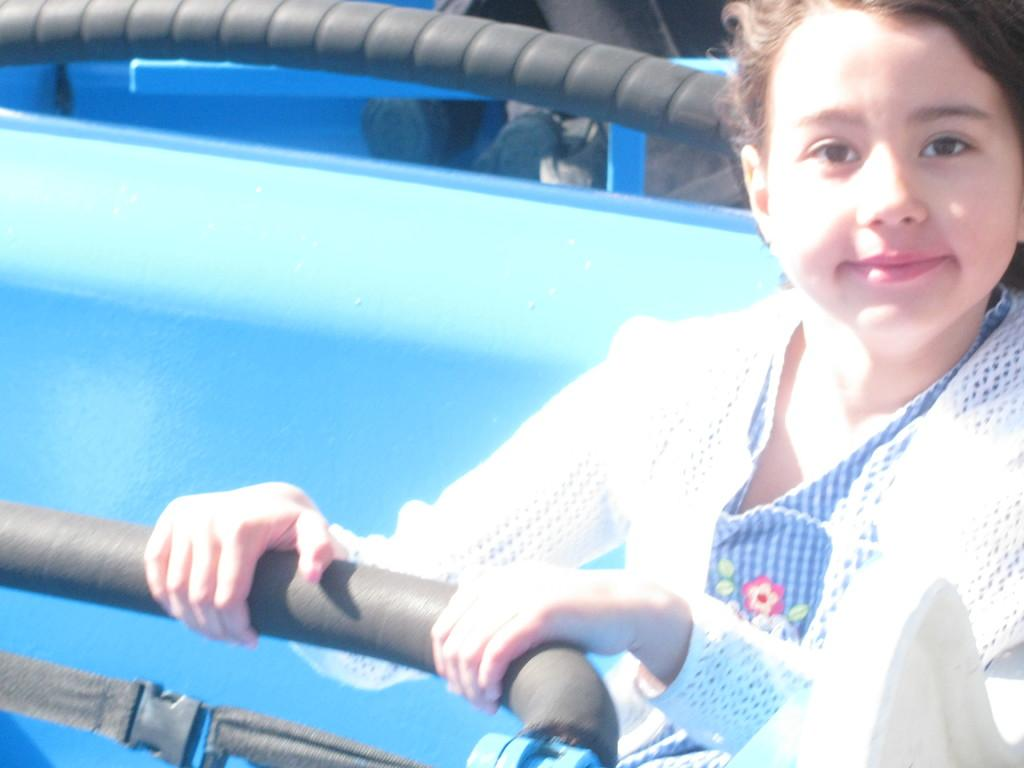What is the person in the cabin doing? The person is sitting in a cabin and holding a rod. What might the person be using the rod for? It is unclear from the image what the person is using the rod for, but it could be for fishing or some other activity. What is located at the bottom of the image? There is a buckle with ropes at the bottom of the image. Can you see a tiger in the image? No, there is no tiger present in the image. What type of coat is the person wearing in the image? The image does not provide enough information to determine the type of coat the person is wearing, if any. 